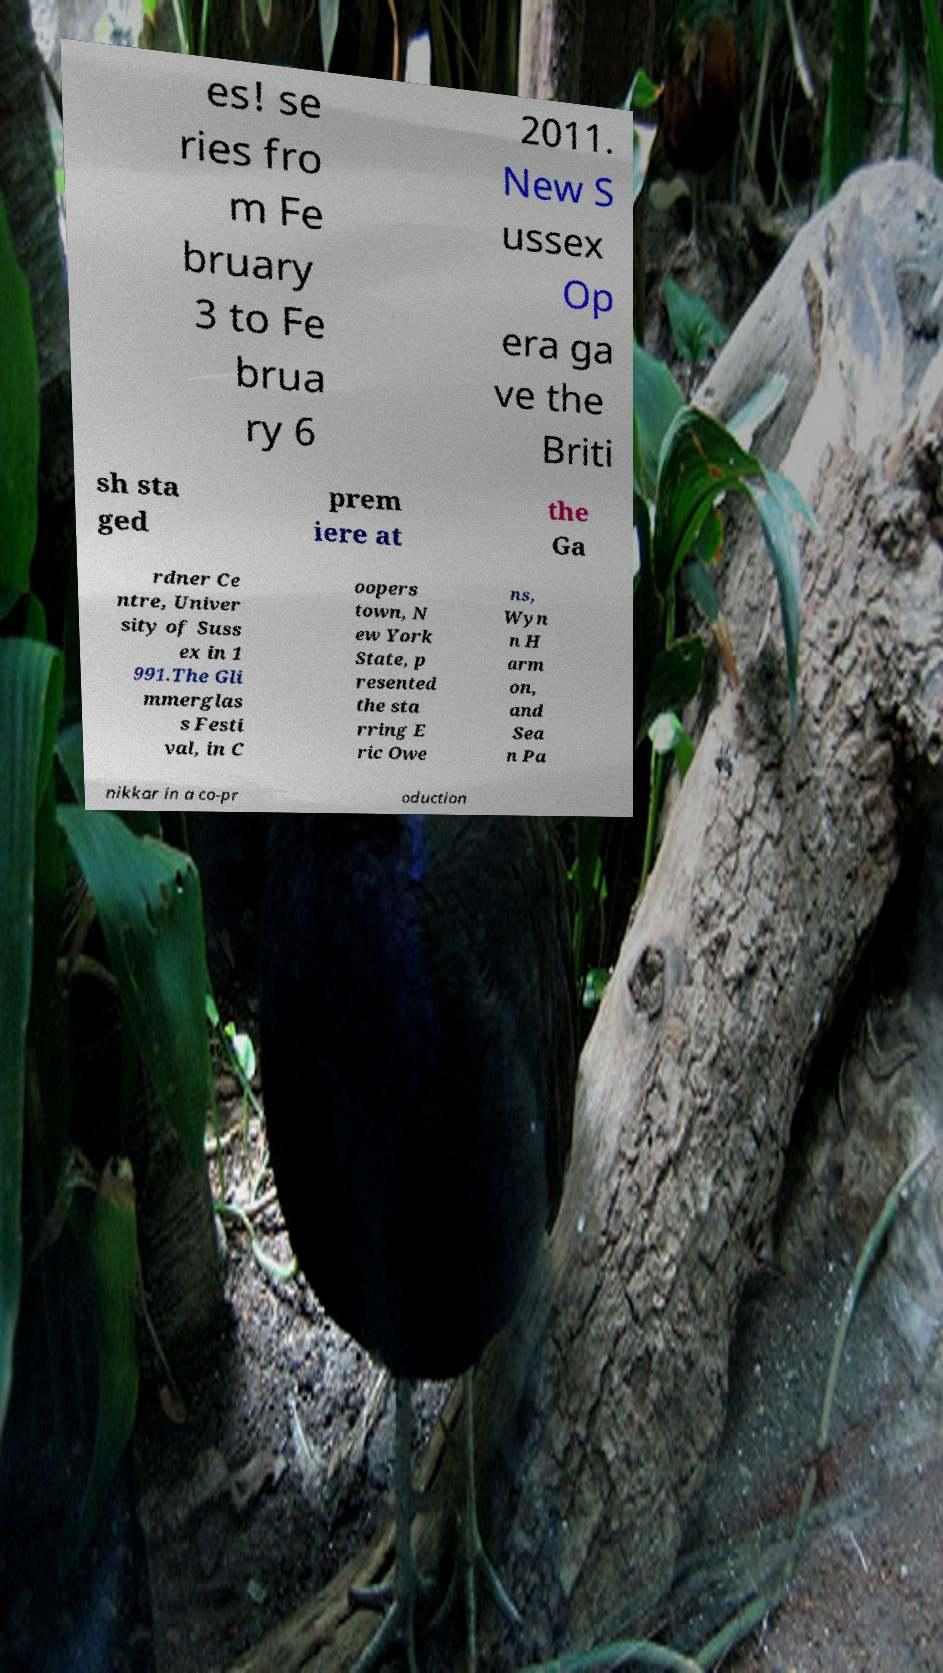Could you assist in decoding the text presented in this image and type it out clearly? es! se ries fro m Fe bruary 3 to Fe brua ry 6 2011. New S ussex Op era ga ve the Briti sh sta ged prem iere at the Ga rdner Ce ntre, Univer sity of Suss ex in 1 991.The Gli mmerglas s Festi val, in C oopers town, N ew York State, p resented the sta rring E ric Owe ns, Wyn n H arm on, and Sea n Pa nikkar in a co-pr oduction 